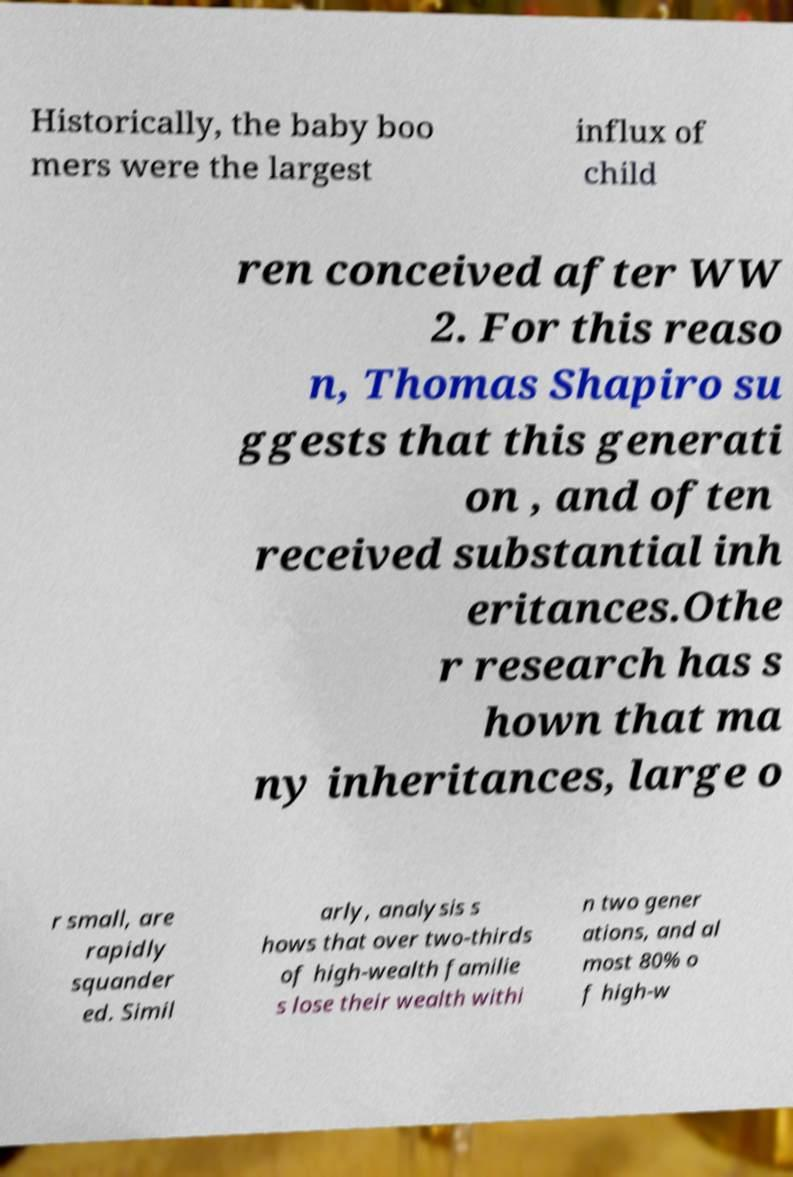Can you accurately transcribe the text from the provided image for me? Historically, the baby boo mers were the largest influx of child ren conceived after WW 2. For this reaso n, Thomas Shapiro su ggests that this generati on , and often received substantial inh eritances.Othe r research has s hown that ma ny inheritances, large o r small, are rapidly squander ed. Simil arly, analysis s hows that over two-thirds of high-wealth familie s lose their wealth withi n two gener ations, and al most 80% o f high-w 